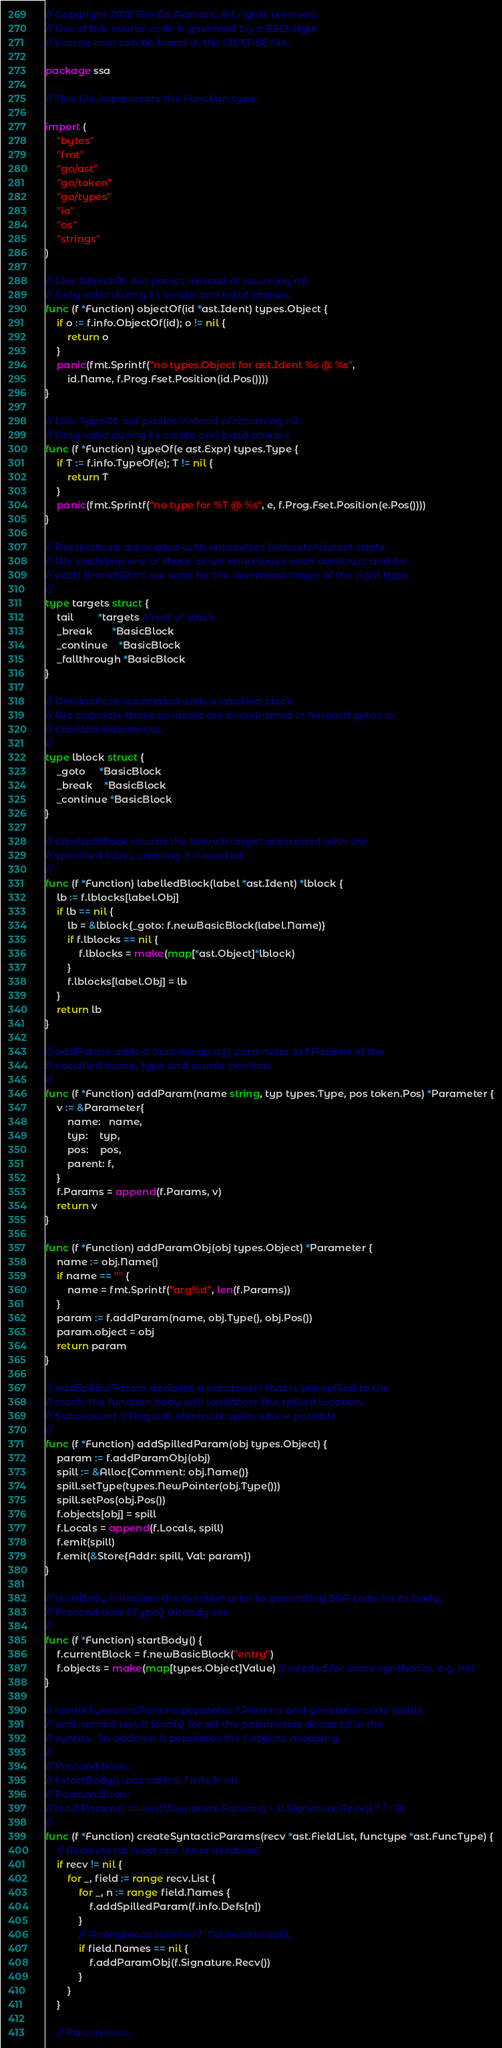<code> <loc_0><loc_0><loc_500><loc_500><_Go_>// Copyright 2013 The Go Authors. All rights reserved.
// Use of this source code is governed by a BSD-style
// license that can be found in the LICENSE file.

package ssa

// This file implements the Function type.

import (
	"bytes"
	"fmt"
	"go/ast"
	"go/token"
	"go/types"
	"io"
	"os"
	"strings"
)

// Like ObjectOf, but panics instead of returning nil.
// Only valid during f's create and build phases.
func (f *Function) objectOf(id *ast.Ident) types.Object {
	if o := f.info.ObjectOf(id); o != nil {
		return o
	}
	panic(fmt.Sprintf("no types.Object for ast.Ident %s @ %s",
		id.Name, f.Prog.Fset.Position(id.Pos())))
}

// Like TypeOf, but panics instead of returning nil.
// Only valid during f's create and build phases.
func (f *Function) typeOf(e ast.Expr) types.Type {
	if T := f.info.TypeOf(e); T != nil {
		return T
	}
	panic(fmt.Sprintf("no type for %T @ %s", e, f.Prog.Fset.Position(e.Pos())))
}

// Destinations associated with unlabelled for/switch/select stmts.
// We push/pop one of these as we enter/leave each construct and for
// each BranchStmt we scan for the innermost target of the right type.
//
type targets struct {
	tail         *targets // rest of stack
	_break       *BasicBlock
	_continue    *BasicBlock
	_fallthrough *BasicBlock
}

// Destinations associated with a labelled block.
// We populate these as labels are encountered in forward gotos or
// labelled statements.
//
type lblock struct {
	_goto     *BasicBlock
	_break    *BasicBlock
	_continue *BasicBlock
}

// labelledBlock returns the branch target associated with the
// specified label, creating it if needed.
//
func (f *Function) labelledBlock(label *ast.Ident) *lblock {
	lb := f.lblocks[label.Obj]
	if lb == nil {
		lb = &lblock{_goto: f.newBasicBlock(label.Name)}
		if f.lblocks == nil {
			f.lblocks = make(map[*ast.Object]*lblock)
		}
		f.lblocks[label.Obj] = lb
	}
	return lb
}

// addParam adds a (non-escaping) parameter to f.Params of the
// specified name, type and source position.
//
func (f *Function) addParam(name string, typ types.Type, pos token.Pos) *Parameter {
	v := &Parameter{
		name:   name,
		typ:    typ,
		pos:    pos,
		parent: f,
	}
	f.Params = append(f.Params, v)
	return v
}

func (f *Function) addParamObj(obj types.Object) *Parameter {
	name := obj.Name()
	if name == "" {
		name = fmt.Sprintf("arg%d", len(f.Params))
	}
	param := f.addParam(name, obj.Type(), obj.Pos())
	param.object = obj
	return param
}

// addSpilledParam declares a parameter that is pre-spilled to the
// stack; the function body will load/store the spilled location.
// Subsequent lifting will eliminate spills where possible.
//
func (f *Function) addSpilledParam(obj types.Object) {
	param := f.addParamObj(obj)
	spill := &Alloc{Comment: obj.Name()}
	spill.setType(types.NewPointer(obj.Type()))
	spill.setPos(obj.Pos())
	f.objects[obj] = spill
	f.Locals = append(f.Locals, spill)
	f.emit(spill)
	f.emit(&Store{Addr: spill, Val: param})
}

// startBody initializes the function prior to generating SSA code for its body.
// Precondition: f.Type() already set.
//
func (f *Function) startBody() {
	f.currentBlock = f.newBasicBlock("entry")
	f.objects = make(map[types.Object]Value) // needed for some synthetics, e.g. init
}

// createSyntacticParams populates f.Params and generates code (spills
// and named result locals) for all the parameters declared in the
// syntax.  In addition it populates the f.objects mapping.
//
// Preconditions:
// f.startBody() was called. f.info != nil.
// Postcondition:
// len(f.Params) == len(f.Signature.Params) + (f.Signature.Recv() ? 1 : 0)
//
func (f *Function) createSyntacticParams(recv *ast.FieldList, functype *ast.FuncType) {
	// Receiver (at most one inner iteration).
	if recv != nil {
		for _, field := range recv.List {
			for _, n := range field.Names {
				f.addSpilledParam(f.info.Defs[n])
			}
			// Anonymous receiver?  No need to spill.
			if field.Names == nil {
				f.addParamObj(f.Signature.Recv())
			}
		}
	}

	// Parameters.</code> 